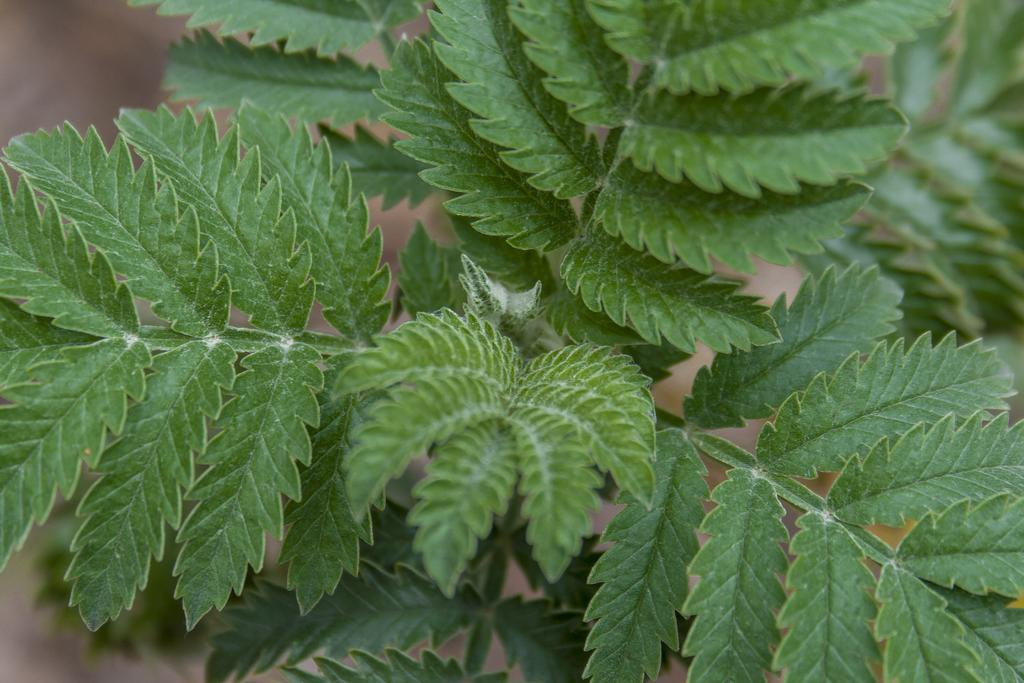What type of plant is visible in the image? There is a plant with leaves in the image. Can you describe the background of the image? The background of the image is blurry. How many apples are resting on the crate in the image? There are no apples or crates present in the image; it only features a plant with leaves and a blurry background. 